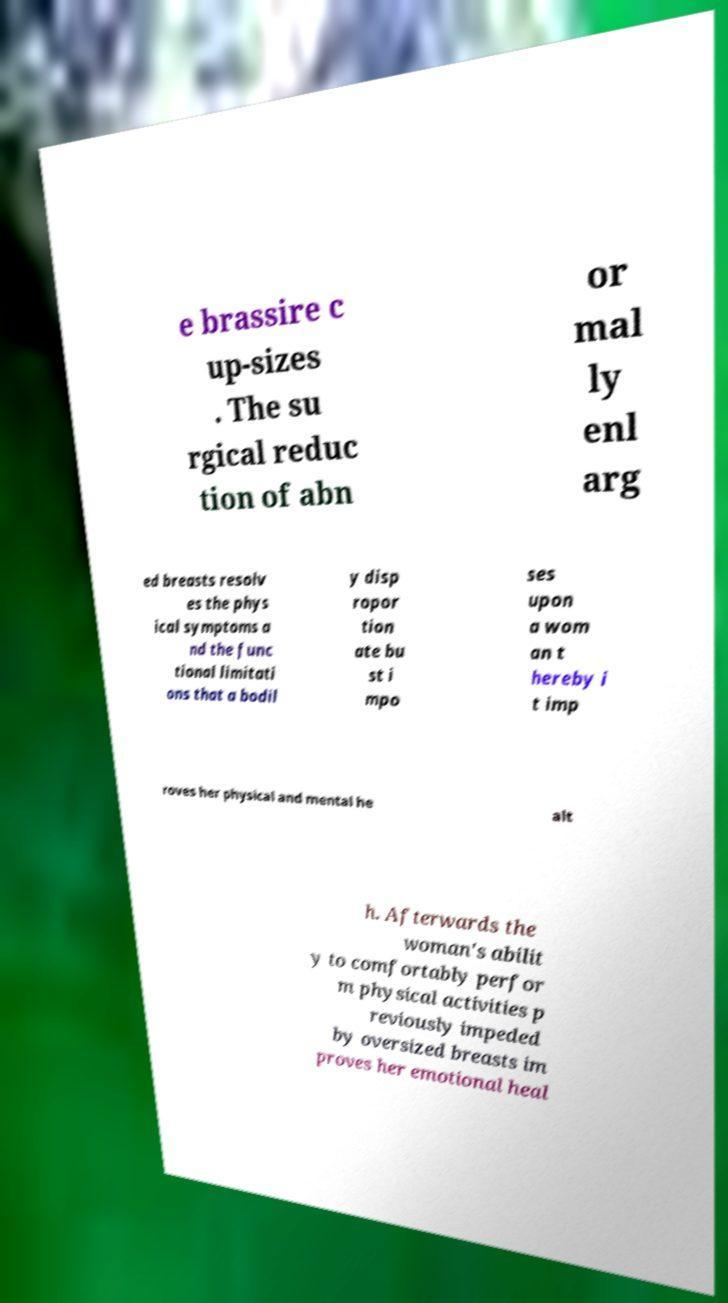Can you read and provide the text displayed in the image?This photo seems to have some interesting text. Can you extract and type it out for me? e brassire c up-sizes . The su rgical reduc tion of abn or mal ly enl arg ed breasts resolv es the phys ical symptoms a nd the func tional limitati ons that a bodil y disp ropor tion ate bu st i mpo ses upon a wom an t hereby i t imp roves her physical and mental he alt h. Afterwards the woman's abilit y to comfortably perfor m physical activities p reviously impeded by oversized breasts im proves her emotional heal 